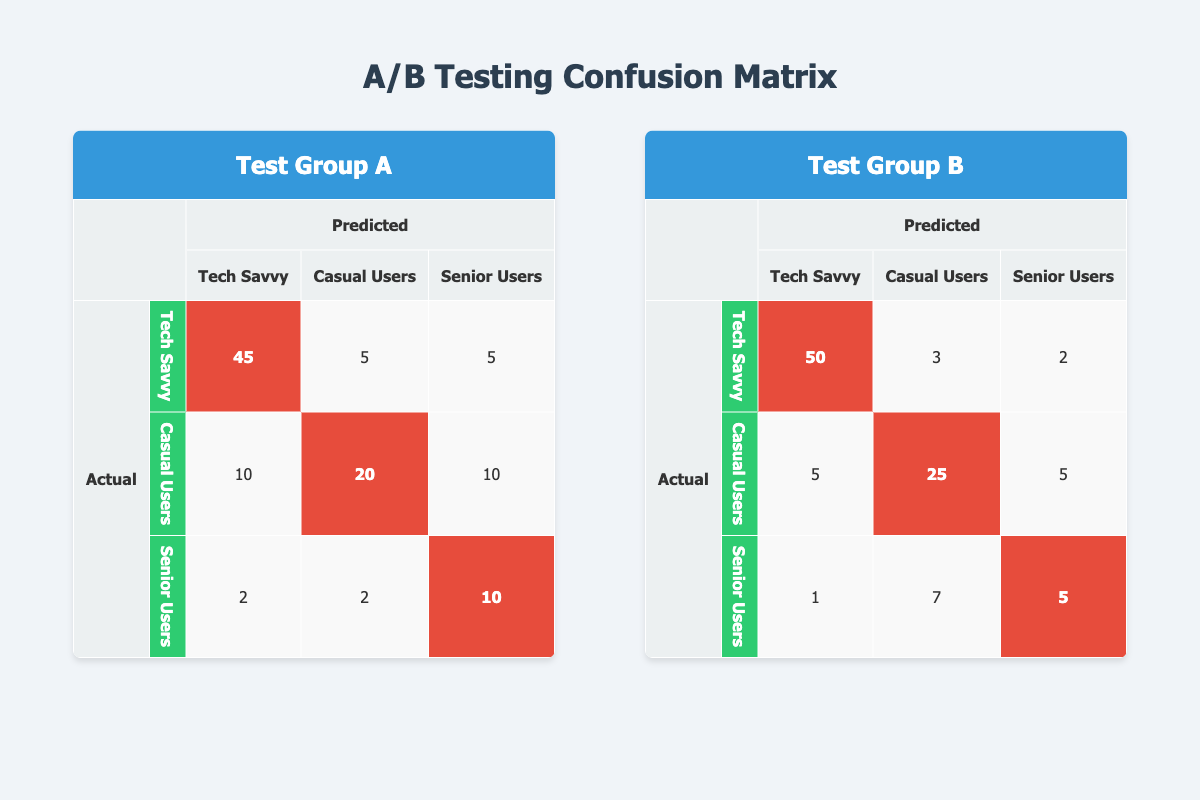What is the number of true positives for Tech Savvy users in Test Group A? In Test Group A, the row for Tech Savvy users indicates that the true positives are 45. This value can be directly found in the confusion matrix for Test Group A.
Answer: 45 What is the false positive count for Casual Users in Test Group B? The confusion matrix for Test Group B shows that Casual Users have a false positive count of 5, which is found in the relevant row for this user segment.
Answer: 5 Which user segment in Test Group A has the highest true positive count? By examining the true positives in Test Group A, Tech Savvy has 45, Casual Users has 20, and Senior Users has 10. Therefore, Tech Savvy has the highest true positive count.
Answer: Tech Savvy What is the total number of true negatives for both Test Groups? Adding the true negatives for both groups: In Test Group A, the true negatives are 30 (Tech Savvy) + 40 (Casual Users) + 36 (Senior Users) = 106. In Test Group B: 28 (Tech Savvy) + 35 (Casual Users) + 38 (Senior Users) = 101. The total true negatives are 106 (A) + 101 (B) = 207.
Answer: 207 Did Senior Users in Test Group A experience more true positives than in Test Group B? In Test Group A, Senior Users had 10 true positives whereas in Test Group B they had 5 true positives. Since 10 > 5, Senior Users did have more true positives in Test Group A.
Answer: Yes What is the total false negative count for Casual Users across both Test Groups? For Casual Users, in Test Group A the false negatives are 10 and in Test Group B they are 5. The total false negatives for Casual Users is 10 + 5 = 15.
Answer: 15 Which Test Group had a higher percentage of true positives for Casual Users? In Test Group A, the true positive percentage for Casual Users is (20 true positives out of 60 total) = 33.33%. In Test Group B, it is (25 true positives out of 55 total) = 45.45%. Thus, Test Group B has a higher percentage.
Answer: Test Group B Calculate the average false positive across all user segments in Test Group A. For Test Group A, the false positives are 5 (Tech Savvy) + 10 (Casual Users) + 2 (Senior Users) = 17. There are 3 user segments, so the average false positive count is 17 / 3 = 5.67.
Answer: 5.67 